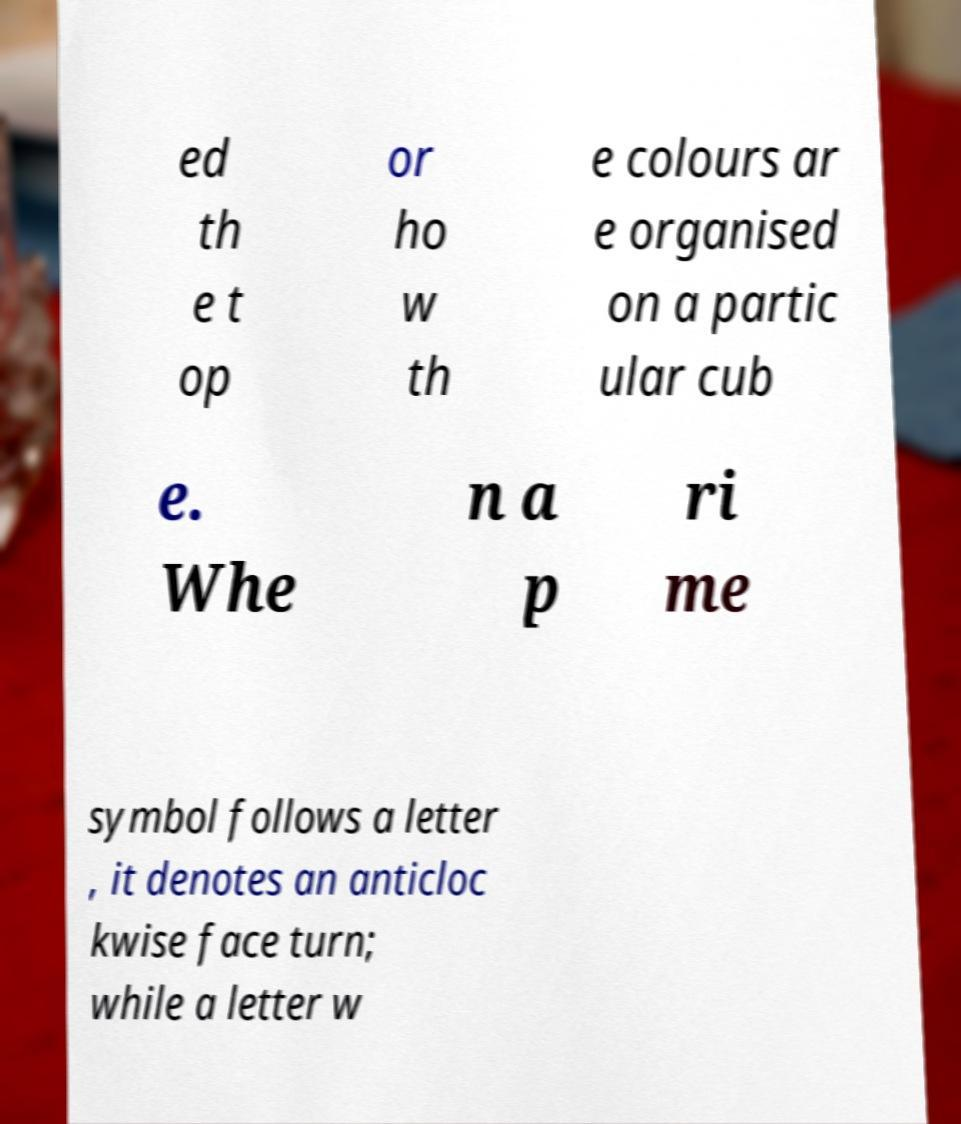There's text embedded in this image that I need extracted. Can you transcribe it verbatim? ed th e t op or ho w th e colours ar e organised on a partic ular cub e. Whe n a p ri me symbol follows a letter , it denotes an anticloc kwise face turn; while a letter w 